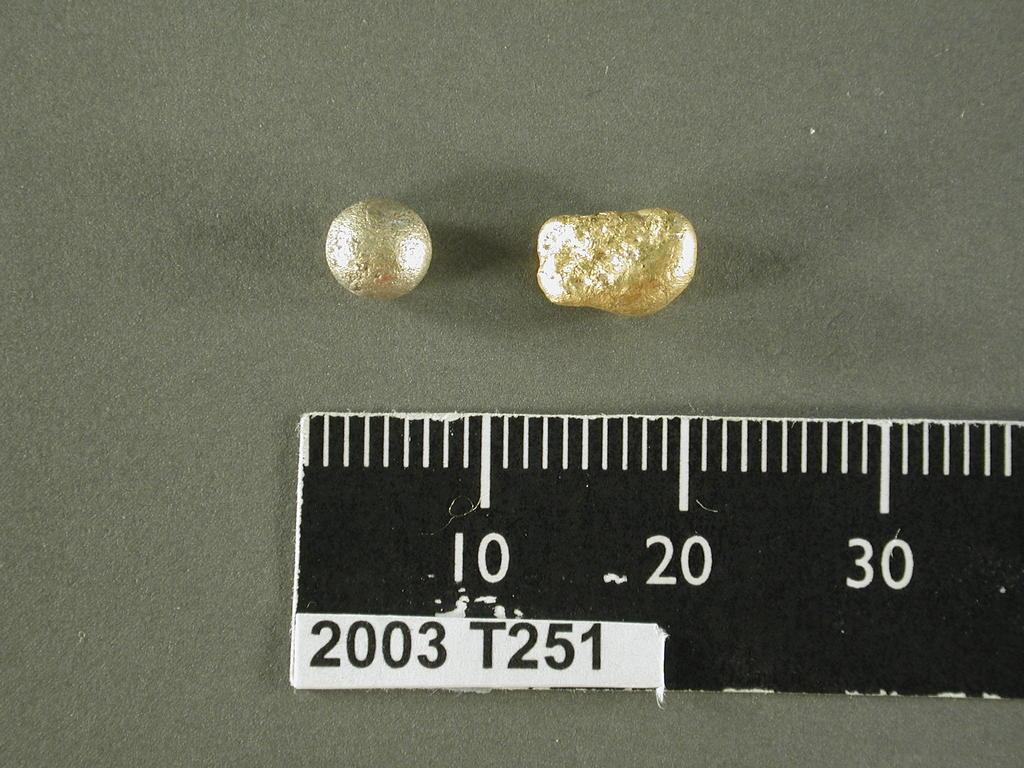<image>
Describe the image concisely. a ruler with many digits on it that include ten 